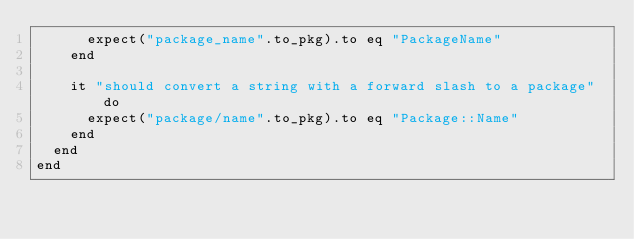<code> <loc_0><loc_0><loc_500><loc_500><_Ruby_>      expect("package_name".to_pkg).to eq "PackageName"
    end

    it "should convert a string with a forward slash to a package" do
      expect("package/name".to_pkg).to eq "Package::Name"
    end
  end
end
</code> 